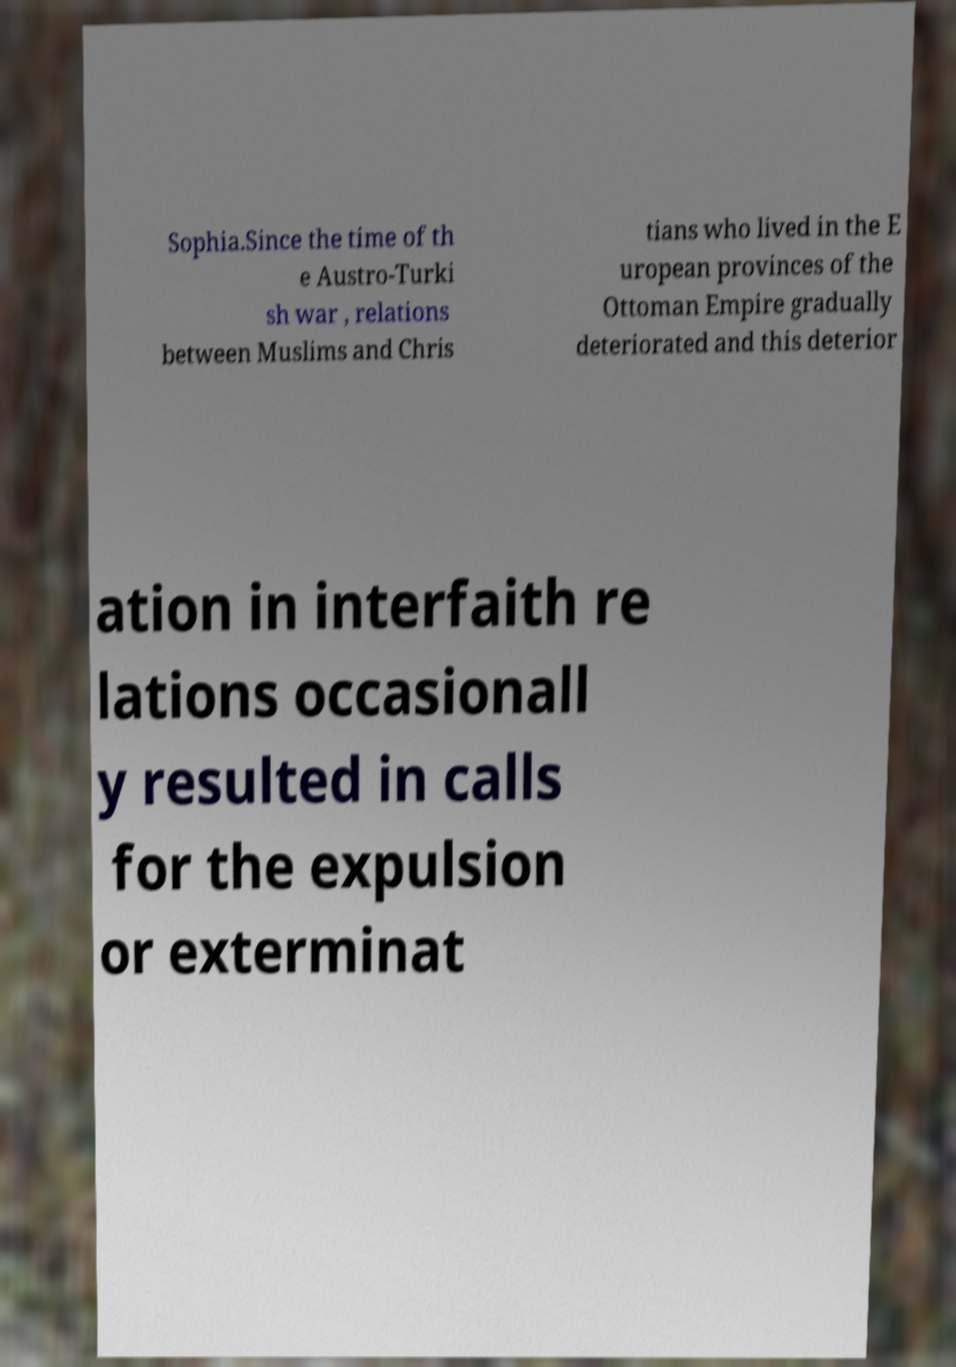Can you accurately transcribe the text from the provided image for me? Sophia.Since the time of th e Austro-Turki sh war , relations between Muslims and Chris tians who lived in the E uropean provinces of the Ottoman Empire gradually deteriorated and this deterior ation in interfaith re lations occasionall y resulted in calls for the expulsion or exterminat 